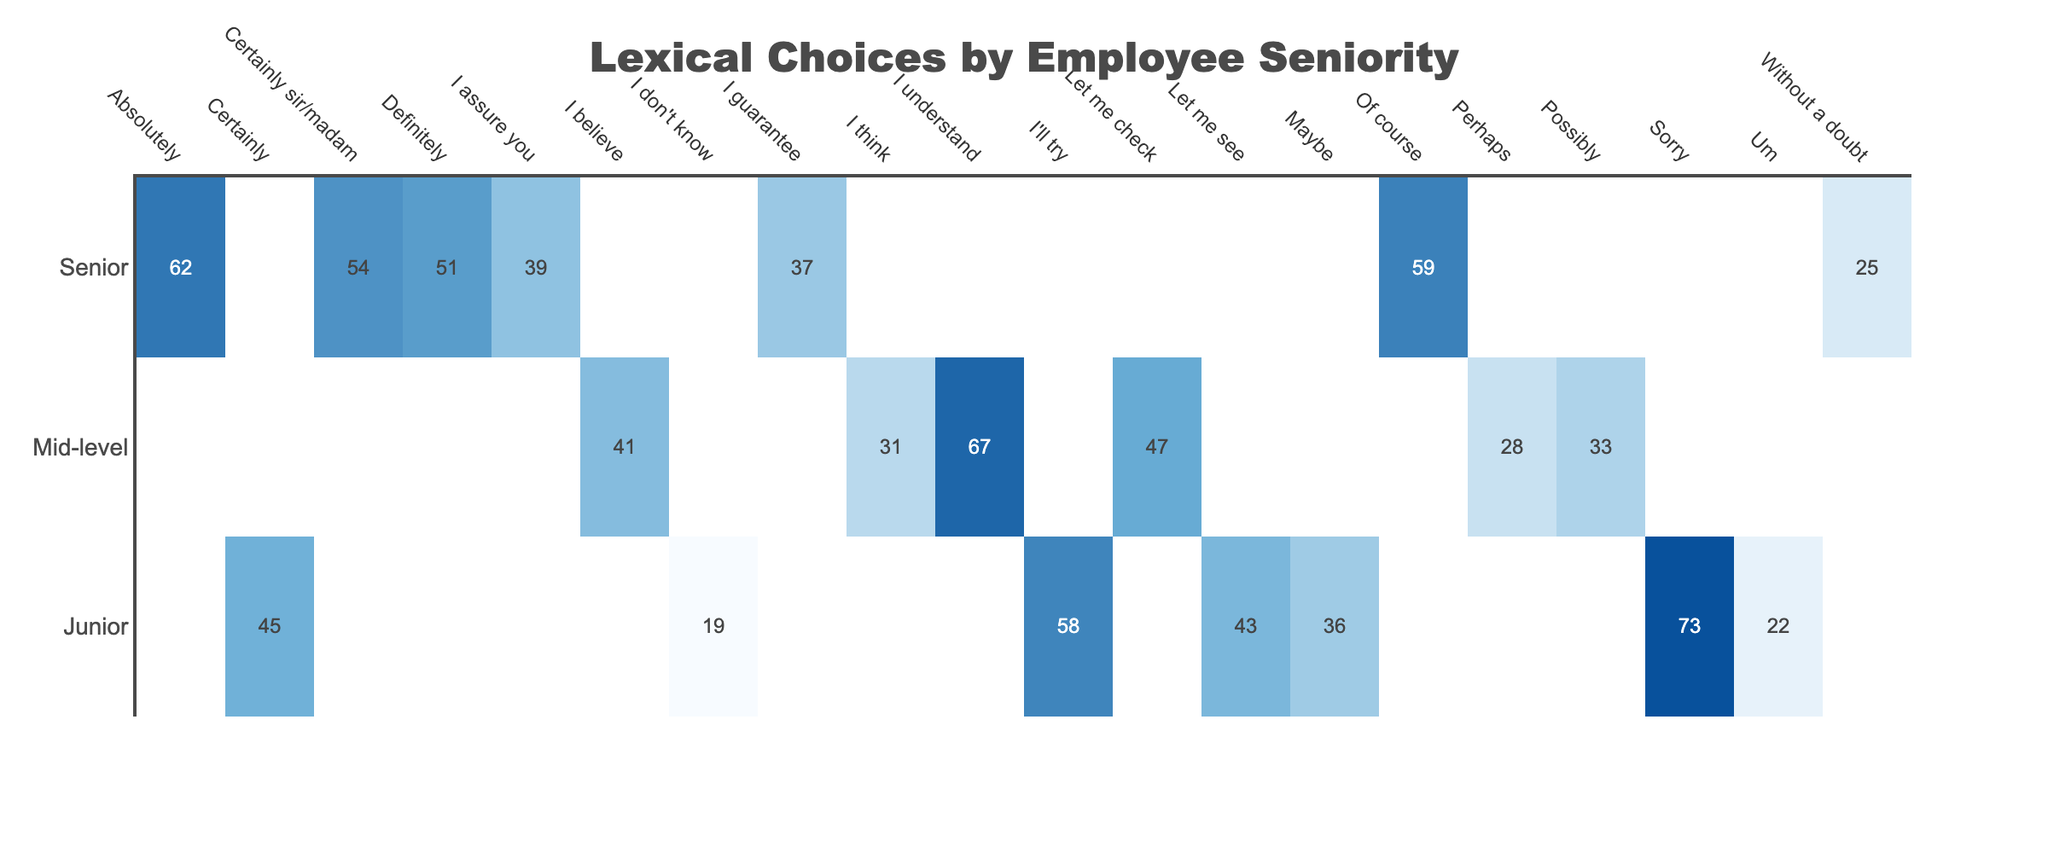What is the highest frequency lexical choice made by senior employees? The table shows that "Certainly sir/madam" with a frequency of 54 is the highest frequency lexical choice for senior employees.
Answer: Certainly sir/madam Which lexical choice has the lowest frequency among junior employees? Looking at the table, the lowest frequency for junior employees is "I don't know," which has a frequency of 19.
Answer: I don't know What is the total frequency of all lexical choices made by mid-level employees? Summing the frequencies for mid-level employees: 28 (Perhaps) + 33 (Possibly) + 47 (Let me check) + 41 (I believe) + 31 (I think) = 210.
Answer: 210 Do senior employees use "Sorry" as a lexical choice? The table shows that "Sorry" does not appear as a lexical choice for senior employees, indicated by the absence of a frequency value.
Answer: No What is the average frequency of all lexical choices made by junior employees? The frequencies for junior employees are 45 (Certainly) + 73 (Sorry) + 58 (I'll try) + 19 (I don't know) + 36 (Maybe) + 22 (Um) + 43 (Let me see) = 396; dividing by 7 gives an average frequency of 396/7 ≈ 56.57, which can be rounded to 57.
Answer: 57 Which senior employee lexical choice has a frequency closest to the mid-level choice "Let me check"? The frequency of "Let me check" for mid-level is 47, and the closest senior lexical choice is "Definitely" which has a frequency of 51.
Answer: Definitely How many more occurrences of "Um" are there among junior employees compared to "I assure you" among senior employees? "Um" has a frequency of 22 among juniors, and "I assure you" has a frequency of 39 among seniors. The difference is 22 - 39 = -17, indicating that "I assure you" occurs 17 more times.
Answer: 17 more occurrences for "I assure you" Which lexical choice shows the highest frequency in customer satisfaction ratings of 4.9? The only lexical choice associated with a customer satisfaction rating of 4.9 is "Certainly sir/madam," which has a frequency of 54.
Answer: Certainly sir/madam Across all senior employees, which is the most commonly used lexical choice? The most frequent choice is "Absolutely" with 62 occurrences, as it has the highest frequency among all lexical choices for senior employees.
Answer: Absolutely If we consider only junior employees, what is the total frequency of positive lexical choices (certainly, I'll try, maybe)? The positive lexical choices are "Certainly" (45), "I'll try" (58), and "Maybe" (36). Their total frequency is 45 + 58 + 36 = 139.
Answer: 139 